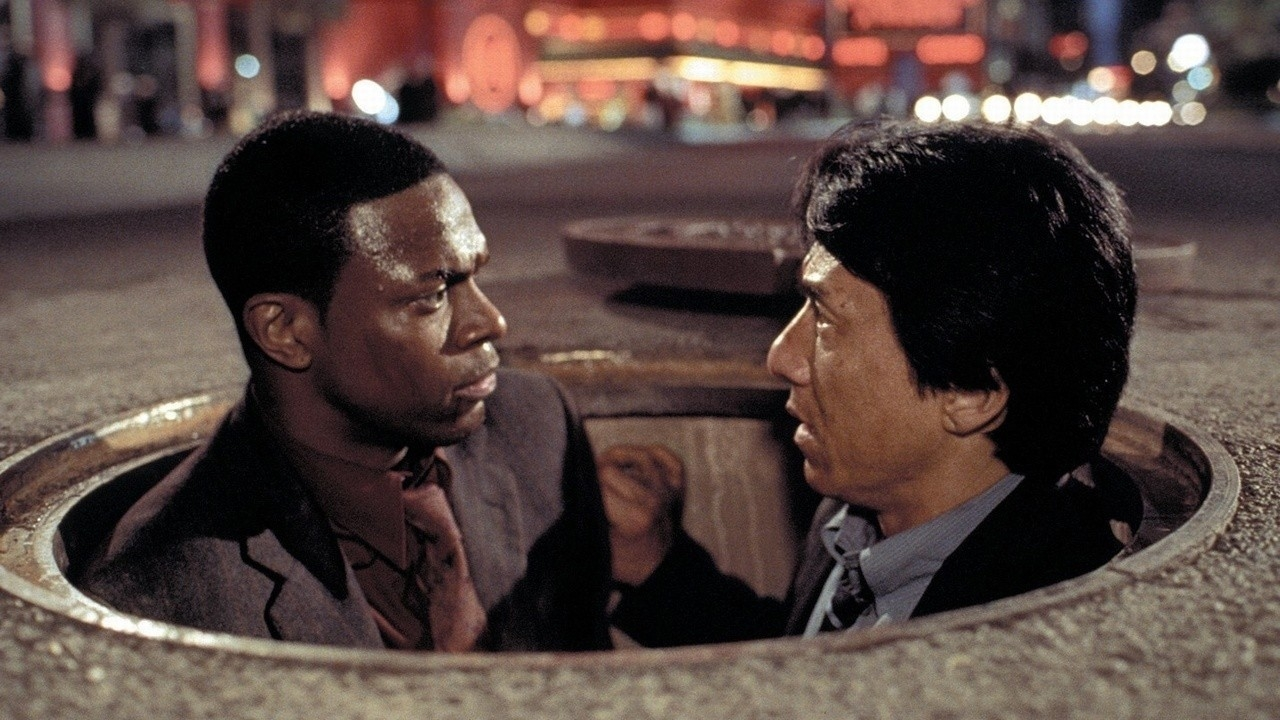Can you elaborate on the elements of the picture provided? In this image, we observe a scene from the movie 'Rush Hour 2' starring actors Chris Tucker and Jackie Chan. The two characters find themselves in a manhole, with Chris Tucker on the left wearing a brown jacket, and Jackie Chan on the right in a black suit. They are giving each other intense looks, creating a serious yet dynamic interaction. This scene takes place on a city street at night, characterized by the vibrant lights and colors of the cityscape in the background. A red-lit fountain and several buildings can be seen, enhancing the ambiance of the urban setting. 